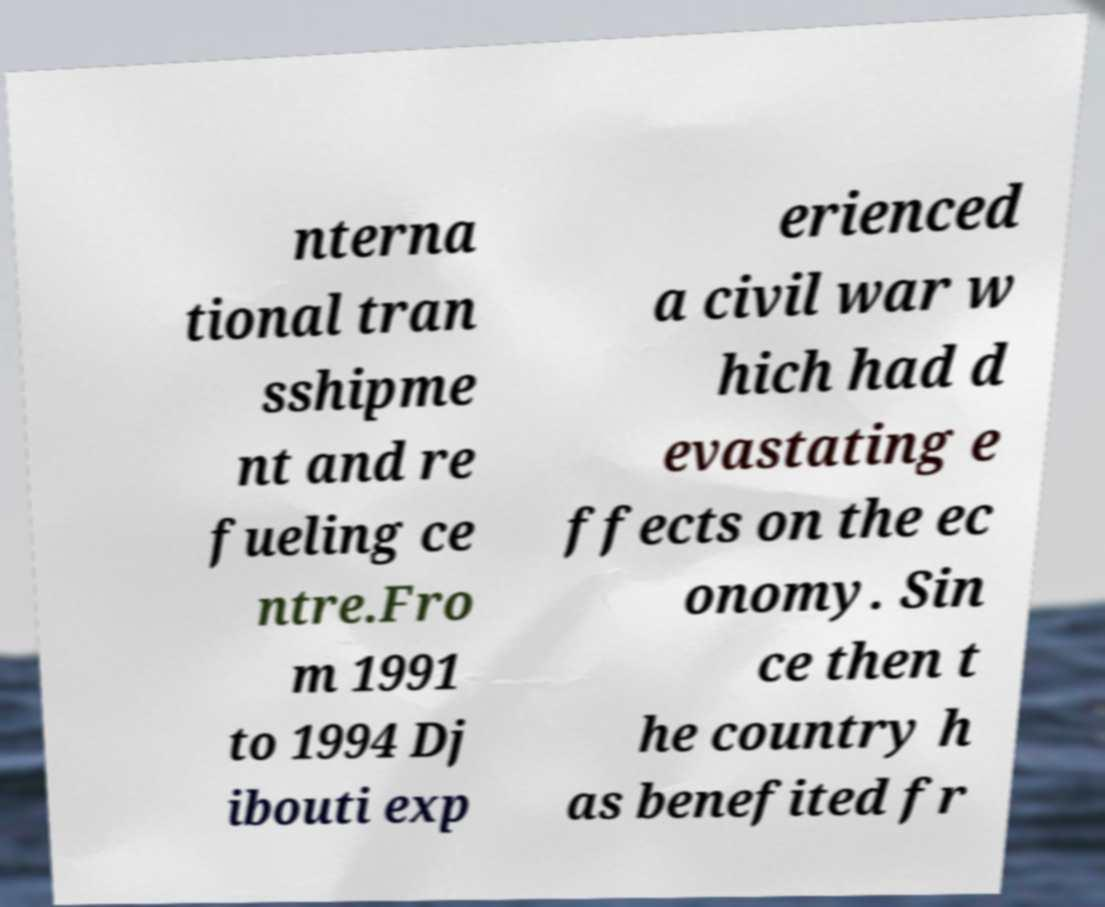Could you extract and type out the text from this image? nterna tional tran sshipme nt and re fueling ce ntre.Fro m 1991 to 1994 Dj ibouti exp erienced a civil war w hich had d evastating e ffects on the ec onomy. Sin ce then t he country h as benefited fr 